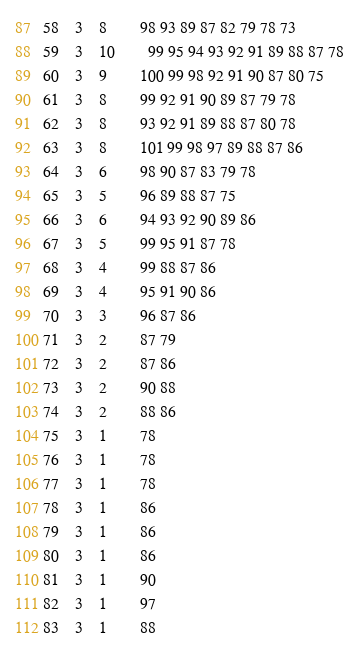Convert code to text. <code><loc_0><loc_0><loc_500><loc_500><_ObjectiveC_>58	3	8		98 93 89 87 82 79 78 73 
59	3	10		99 95 94 93 92 91 89 88 87 78 
60	3	9		100 99 98 92 91 90 87 80 75 
61	3	8		99 92 91 90 89 87 79 78 
62	3	8		93 92 91 89 88 87 80 78 
63	3	8		101 99 98 97 89 88 87 86 
64	3	6		98 90 87 83 79 78 
65	3	5		96 89 88 87 75 
66	3	6		94 93 92 90 89 86 
67	3	5		99 95 91 87 78 
68	3	4		99 88 87 86 
69	3	4		95 91 90 86 
70	3	3		96 87 86 
71	3	2		87 79 
72	3	2		87 86 
73	3	2		90 88 
74	3	2		88 86 
75	3	1		78 
76	3	1		78 
77	3	1		78 
78	3	1		86 
79	3	1		86 
80	3	1		86 
81	3	1		90 
82	3	1		97 
83	3	1		88 </code> 